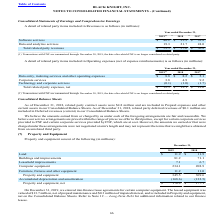According to Black Knight Financial Services's financial document, What was the date after which FNF was no longer considered a related party? According to the financial document, November 30, 2019. The relevant text states: "(1) Transactions with FNF are summarized through November 30, 2019, the date after which FNF is no longer considered a related party...." Also, What was the amount of Corporate Services in 2018? According to the financial document, 4.9 (in millions). The relevant text states: "Corporate services 3.8 4.9 9.2..." Also, Which years does the table provide information for related party items included in Operating expenses (net of expense reimbursements)? The document contains multiple relevant values: 2019, 2018, 2017. From the document: "2019 (1) 2018 2017 2019 (1) 2018 2017 2019 (1) 2018 2017..." Also, can you calculate: What was the change in corporate services between 2017 and 2018? Based on the calculation: 4.9-9.2, the result is -4.3 (in millions). This is based on the information: "Corporate services 3.8 4.9 9.2 Corporate services 3.8 4.9 9.2..." The key data points involved are: 4.9, 9.2. Also, can you calculate: What was the change in Total related party expenses, net between 2018 and 2019? Based on the calculation: 12.5-12.1, the result is 0.4 (in millions). This is based on the information: "Total related party expenses, net $ 12.5 $ 12.1 $ 12.6 Total related party expenses, net $ 12.5 $ 12.1 $ 12.6..." The key data points involved are: 12.1, 12.5. Also, can you calculate: What was the percentage change in Technology and corporate services between 2017 and 2018? To answer this question, I need to perform calculations using the financial data. The calculation is: (-1.0-(-1.7))/-1.7, which equals -41.18 (percentage). This is based on the information: "Technology and corporate services (0.1) (1.0) (1.7) Technology and corporate services (0.1) (1.0) (1.7)..." The key data points involved are: 1.0, 1.7. 